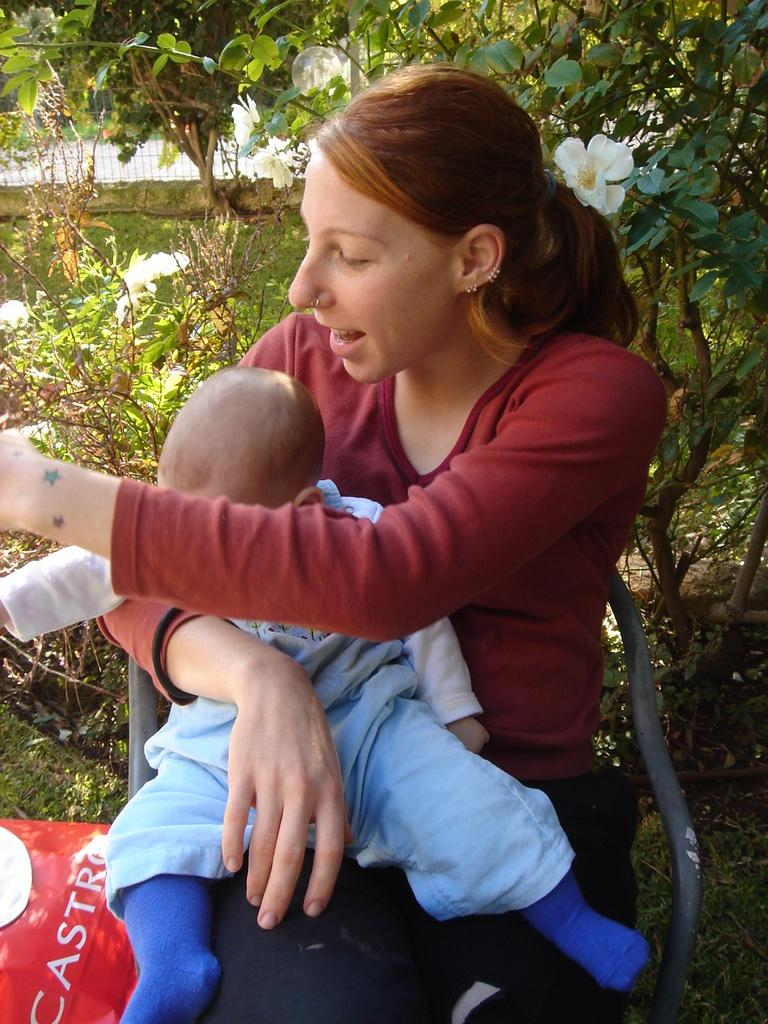Who is the main subject in the image? There is a woman in the image. What is the woman doing in the image? The woman is holding a baby. What is the woman's position in the image? The woman is sitting on a chair. What type of vegetation can be seen in the image? There are trees in the background of the image. What is visible in the background of the image besides trees? There is fencing in the background of the image. How far away is the blade from the woman in the image? There is no blade present in the image. 